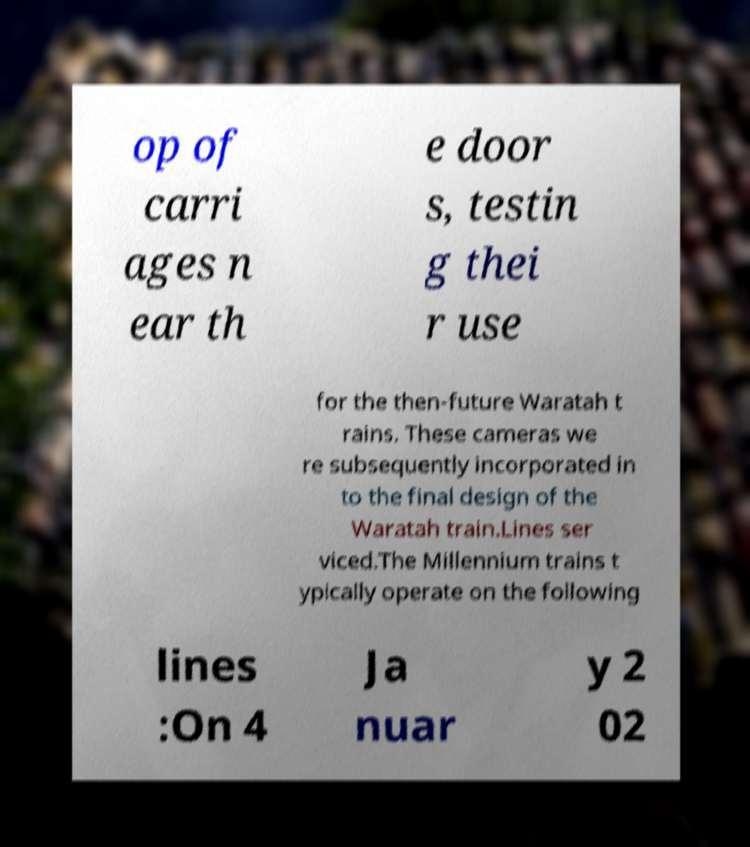Please read and relay the text visible in this image. What does it say? op of carri ages n ear th e door s, testin g thei r use for the then-future Waratah t rains. These cameras we re subsequently incorporated in to the final design of the Waratah train.Lines ser viced.The Millennium trains t ypically operate on the following lines :On 4 Ja nuar y 2 02 